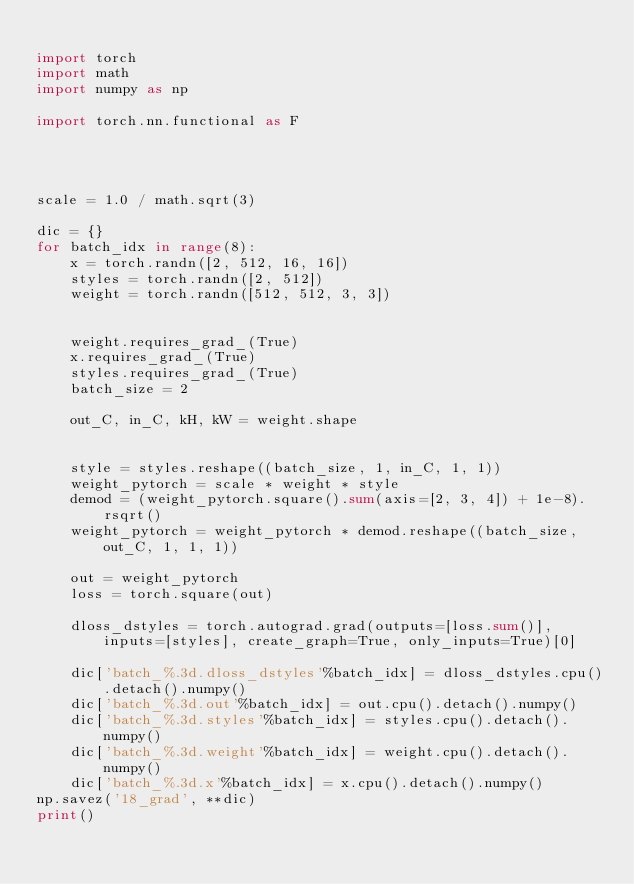<code> <loc_0><loc_0><loc_500><loc_500><_Python_>
import torch
import math
import numpy as np

import torch.nn.functional as F




scale = 1.0 / math.sqrt(3)

dic = {}
for batch_idx in range(8):
    x = torch.randn([2, 512, 16, 16])
    styles = torch.randn([2, 512])
    weight = torch.randn([512, 512, 3, 3])


    weight.requires_grad_(True)
    x.requires_grad_(True)
    styles.requires_grad_(True)
    batch_size = 2

    out_C, in_C, kH, kW = weight.shape


    style = styles.reshape((batch_size, 1, in_C, 1, 1))
    weight_pytorch = scale * weight * style
    demod = (weight_pytorch.square().sum(axis=[2, 3, 4]) + 1e-8).rsqrt()
    weight_pytorch = weight_pytorch * demod.reshape((batch_size, out_C, 1, 1, 1))

    out = weight_pytorch
    loss = torch.square(out)

    dloss_dstyles = torch.autograd.grad(outputs=[loss.sum()], inputs=[styles], create_graph=True, only_inputs=True)[0]

    dic['batch_%.3d.dloss_dstyles'%batch_idx] = dloss_dstyles.cpu().detach().numpy()
    dic['batch_%.3d.out'%batch_idx] = out.cpu().detach().numpy()
    dic['batch_%.3d.styles'%batch_idx] = styles.cpu().detach().numpy()
    dic['batch_%.3d.weight'%batch_idx] = weight.cpu().detach().numpy()
    dic['batch_%.3d.x'%batch_idx] = x.cpu().detach().numpy()
np.savez('18_grad', **dic)
print()
</code> 